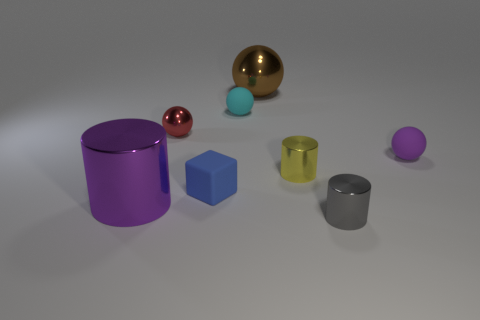What material is the brown object?
Your response must be concise. Metal. How many objects are both in front of the yellow metal thing and right of the large purple cylinder?
Provide a succinct answer. 2. Does the brown metallic sphere have the same size as the yellow metallic cylinder?
Keep it short and to the point. No. Do the thing that is left of the red shiny object and the big sphere have the same size?
Make the answer very short. Yes. The rubber object that is in front of the tiny purple rubber ball is what color?
Offer a very short reply. Blue. How many tiny cubes are there?
Provide a succinct answer. 1. The large brown thing that is made of the same material as the yellow object is what shape?
Ensure brevity in your answer.  Sphere. There is a sphere right of the small gray metallic thing; is its color the same as the big object that is on the left side of the tiny blue matte thing?
Provide a short and direct response. Yes. Are there an equal number of tiny balls that are behind the red metallic object and tiny purple cubes?
Ensure brevity in your answer.  No. What number of purple matte objects are on the left side of the purple cylinder?
Offer a very short reply. 0. 